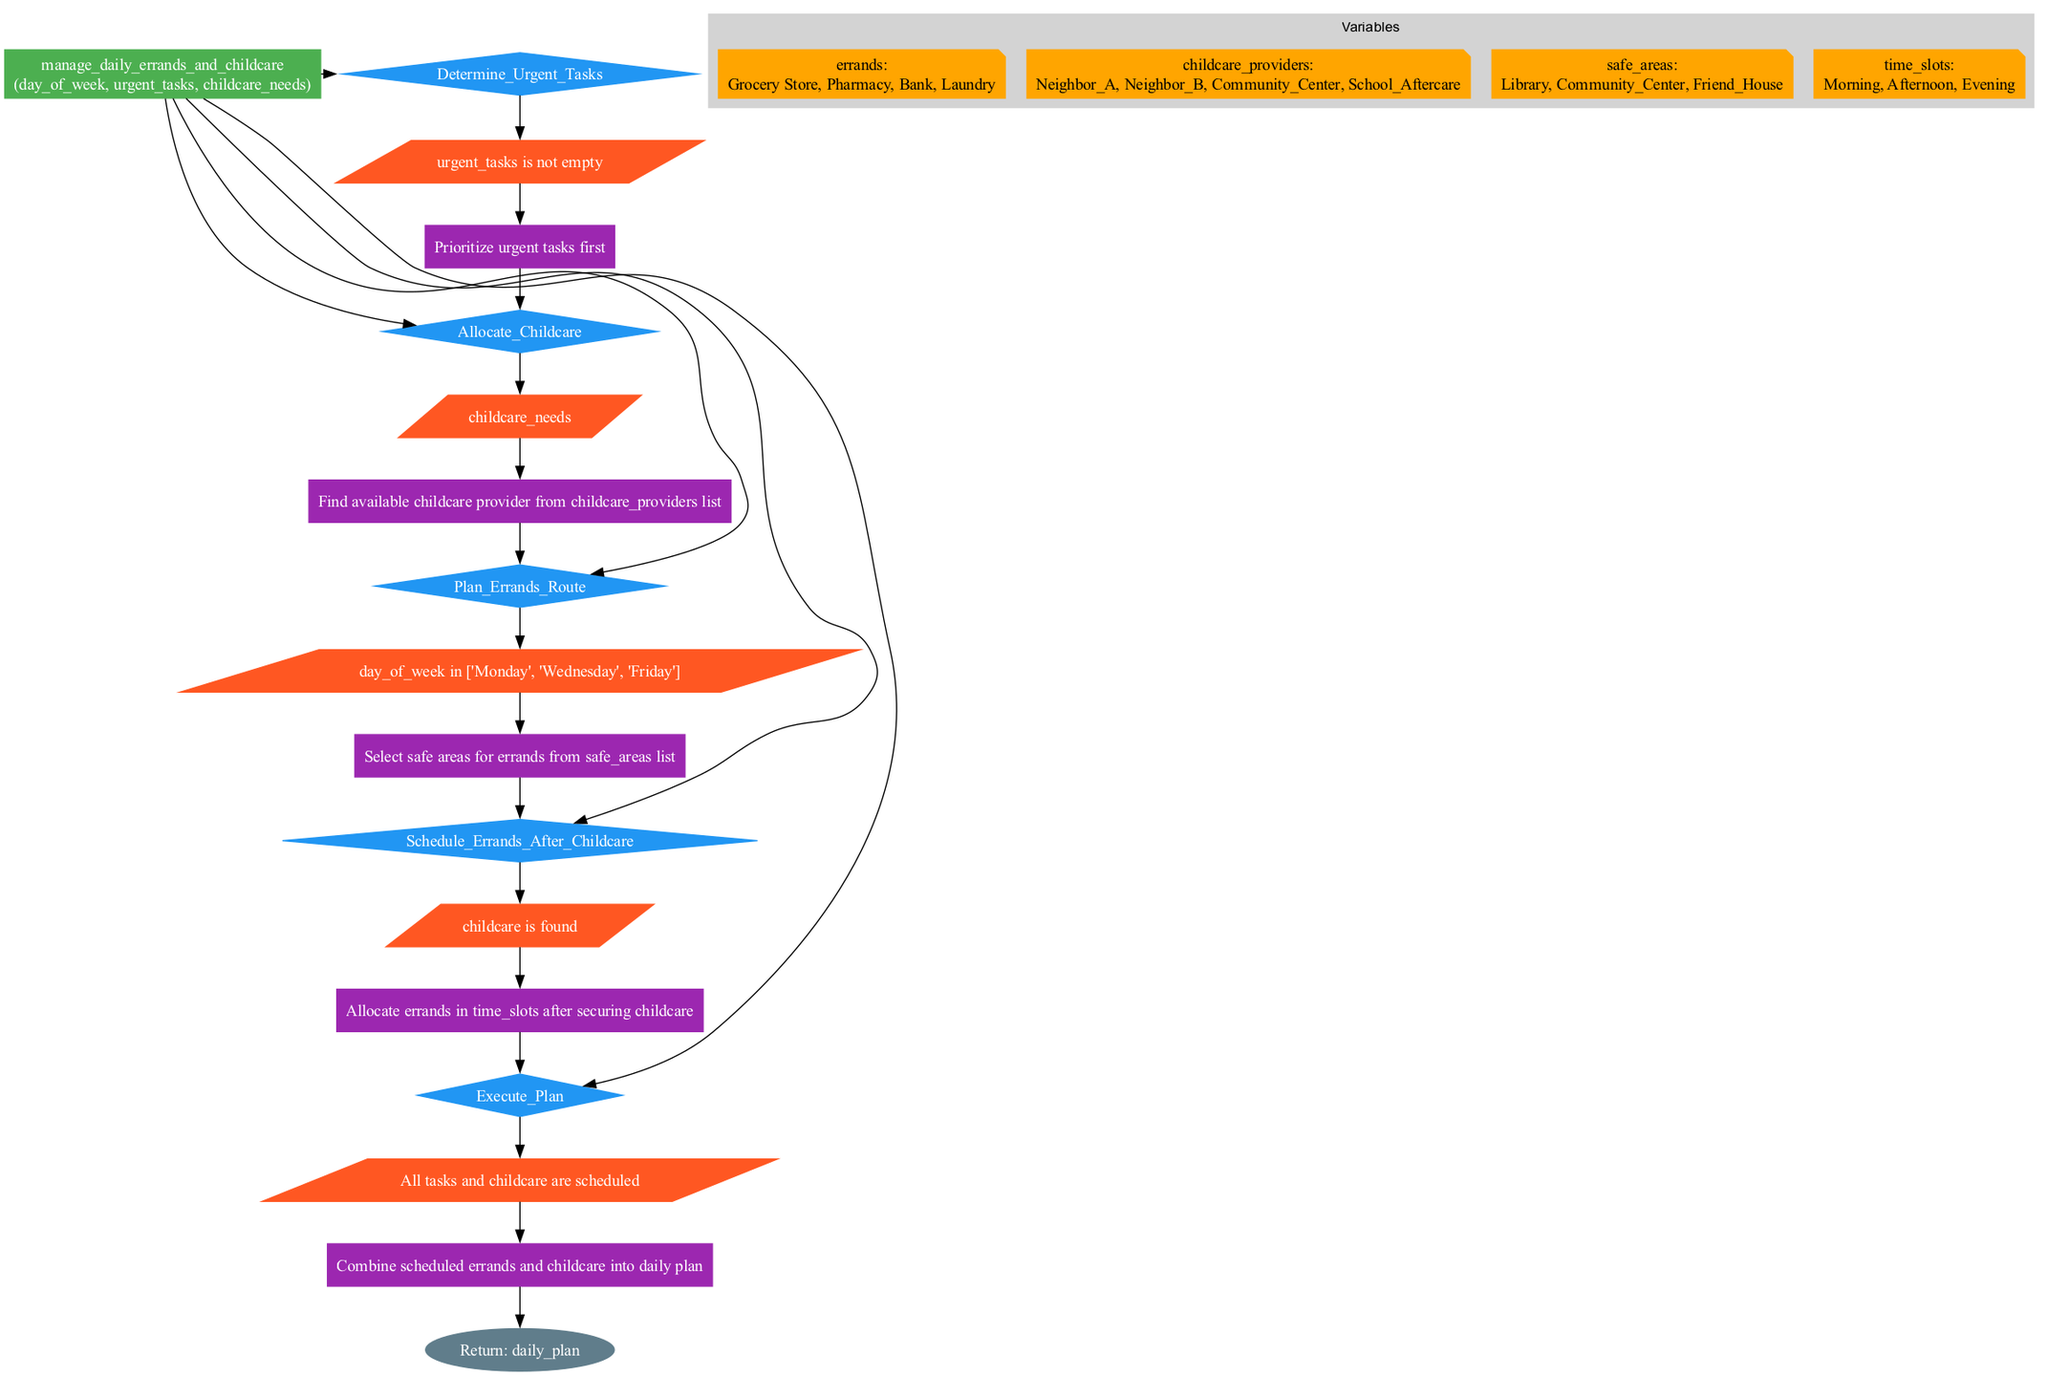What is the first step in the flowchart? The first step is "Determine_Urgent_Tasks". This step is the initial action in the sequence of steps outlined in the function for managing errands and childcare.
Answer: Determine_Urgent_Tasks How many variables are defined in the diagram? There are four variables defined: errands, childcare_providers, safe_areas, and time_slots. This can be counted in the variables section of the diagram.
Answer: Four What happens if urgent_tasks is empty? If urgent_tasks is empty, the step "Determine_Urgent_Tasks" is skipped, and the process moves to the next step without prioritizing any urgent tasks. The condition for this step specifically checks if there are urgent tasks.
Answer: Skip prioritization Which step comes after "Allocate_Childcare"? The step that comes after "Allocate_Childcare" is "Plan_Errands_Route". The flow of the diagram shows a direct connection from the childcare allocation to planning the route for errands.
Answer: Plan_Errands_Route What is the action taken when childcare needs are identified? The action taken is "Find available childcare provider from childcare_providers list". This action is specifically tied to the step of allocating childcare based on the identified needs.
Answer: Find available childcare provider If all tasks and childcare are scheduled, what is the final output? The final output when all tasks and childcare are scheduled is "daily_plan". The flowchart culminates in returning this daily plan once everything is organized.
Answer: daily_plan What is the condition checked before planning errands on specific days? The condition checked is whether the "day_of_week is in ['Monday', 'Wednesday', 'Friday']". This specifies that errands are only planned on these days.
Answer: day_of_week in ['Monday', 'Wednesday', 'Friday'] How many childcare providers are available according to the diagram? There are four childcare providers available: Neighbor_A, Neighbor_B, Community_Center, and School_Aftercare. This information can be found in the childcare_providers variable.
Answer: Four What is the shape of the node representing the function? The shape of the node representing the function is a box. In flowcharts, a box shape typically indicates a function or process element.
Answer: Box 